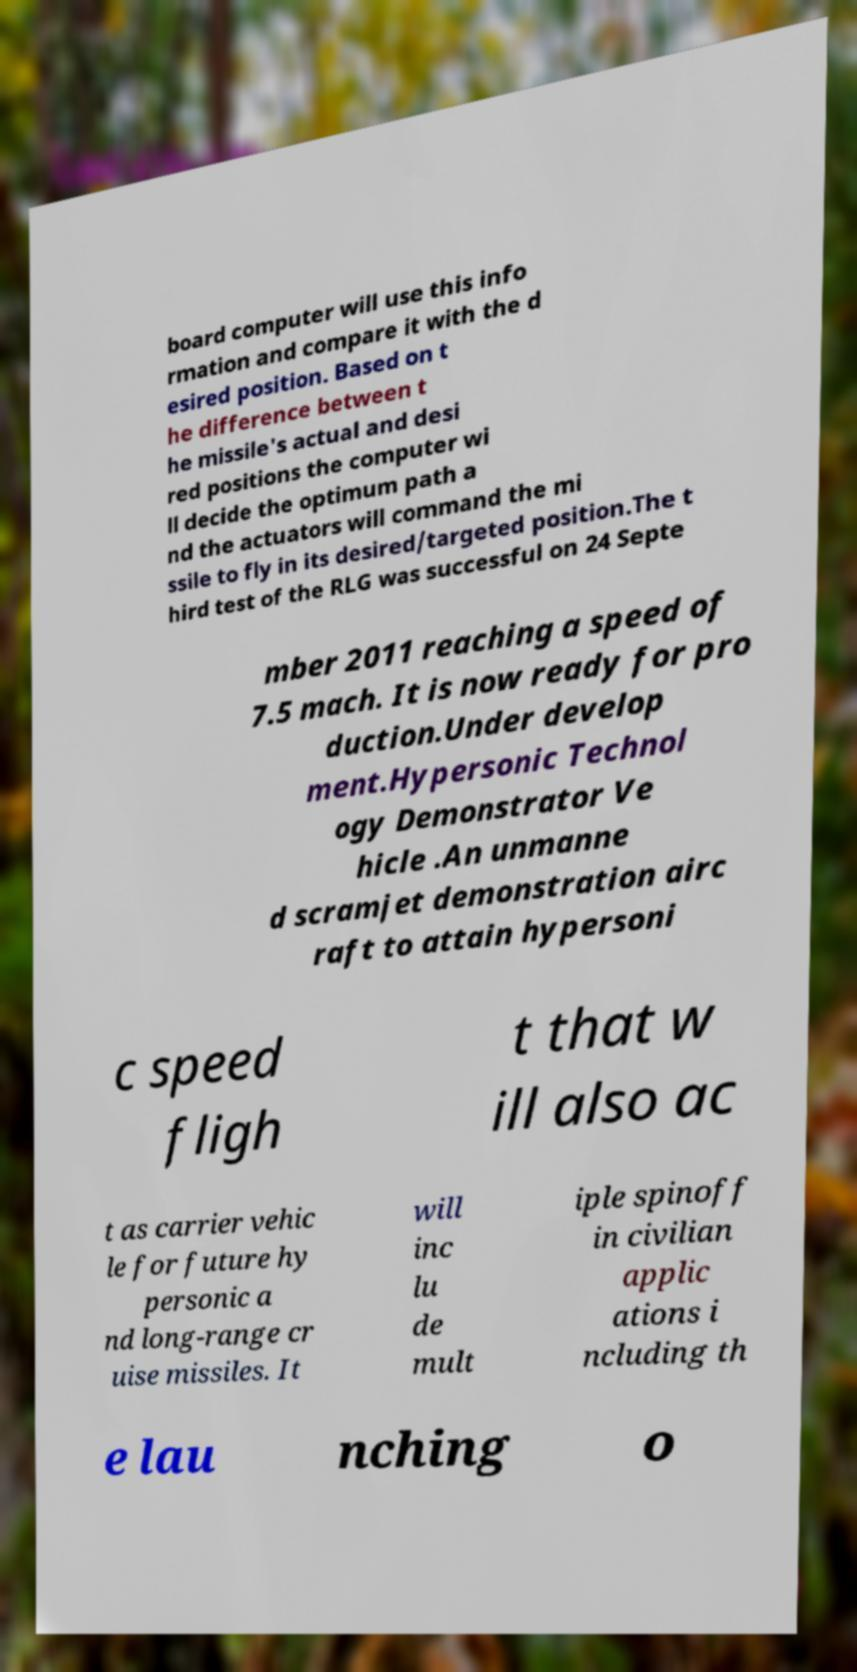Could you extract and type out the text from this image? board computer will use this info rmation and compare it with the d esired position. Based on t he difference between t he missile's actual and desi red positions the computer wi ll decide the optimum path a nd the actuators will command the mi ssile to fly in its desired/targeted position.The t hird test of the RLG was successful on 24 Septe mber 2011 reaching a speed of 7.5 mach. It is now ready for pro duction.Under develop ment.Hypersonic Technol ogy Demonstrator Ve hicle .An unmanne d scramjet demonstration airc raft to attain hypersoni c speed fligh t that w ill also ac t as carrier vehic le for future hy personic a nd long-range cr uise missiles. It will inc lu de mult iple spinoff in civilian applic ations i ncluding th e lau nching o 